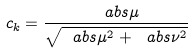<formula> <loc_0><loc_0><loc_500><loc_500>c _ { k } = \frac { \ a b s { \mu } } { \sqrt { \ a b s { \mu } ^ { 2 } + \ a b s { \nu } ^ { 2 } } }</formula> 